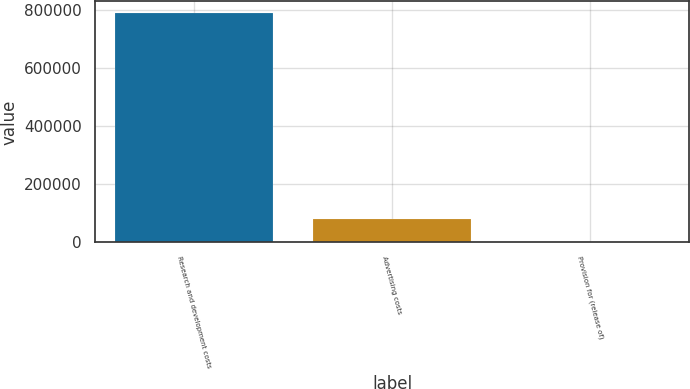Convert chart. <chart><loc_0><loc_0><loc_500><loc_500><bar_chart><fcel>Research and development costs<fcel>Advertising costs<fcel>Provision for (release of)<nl><fcel>790779<fcel>80031.9<fcel>1060<nl></chart> 